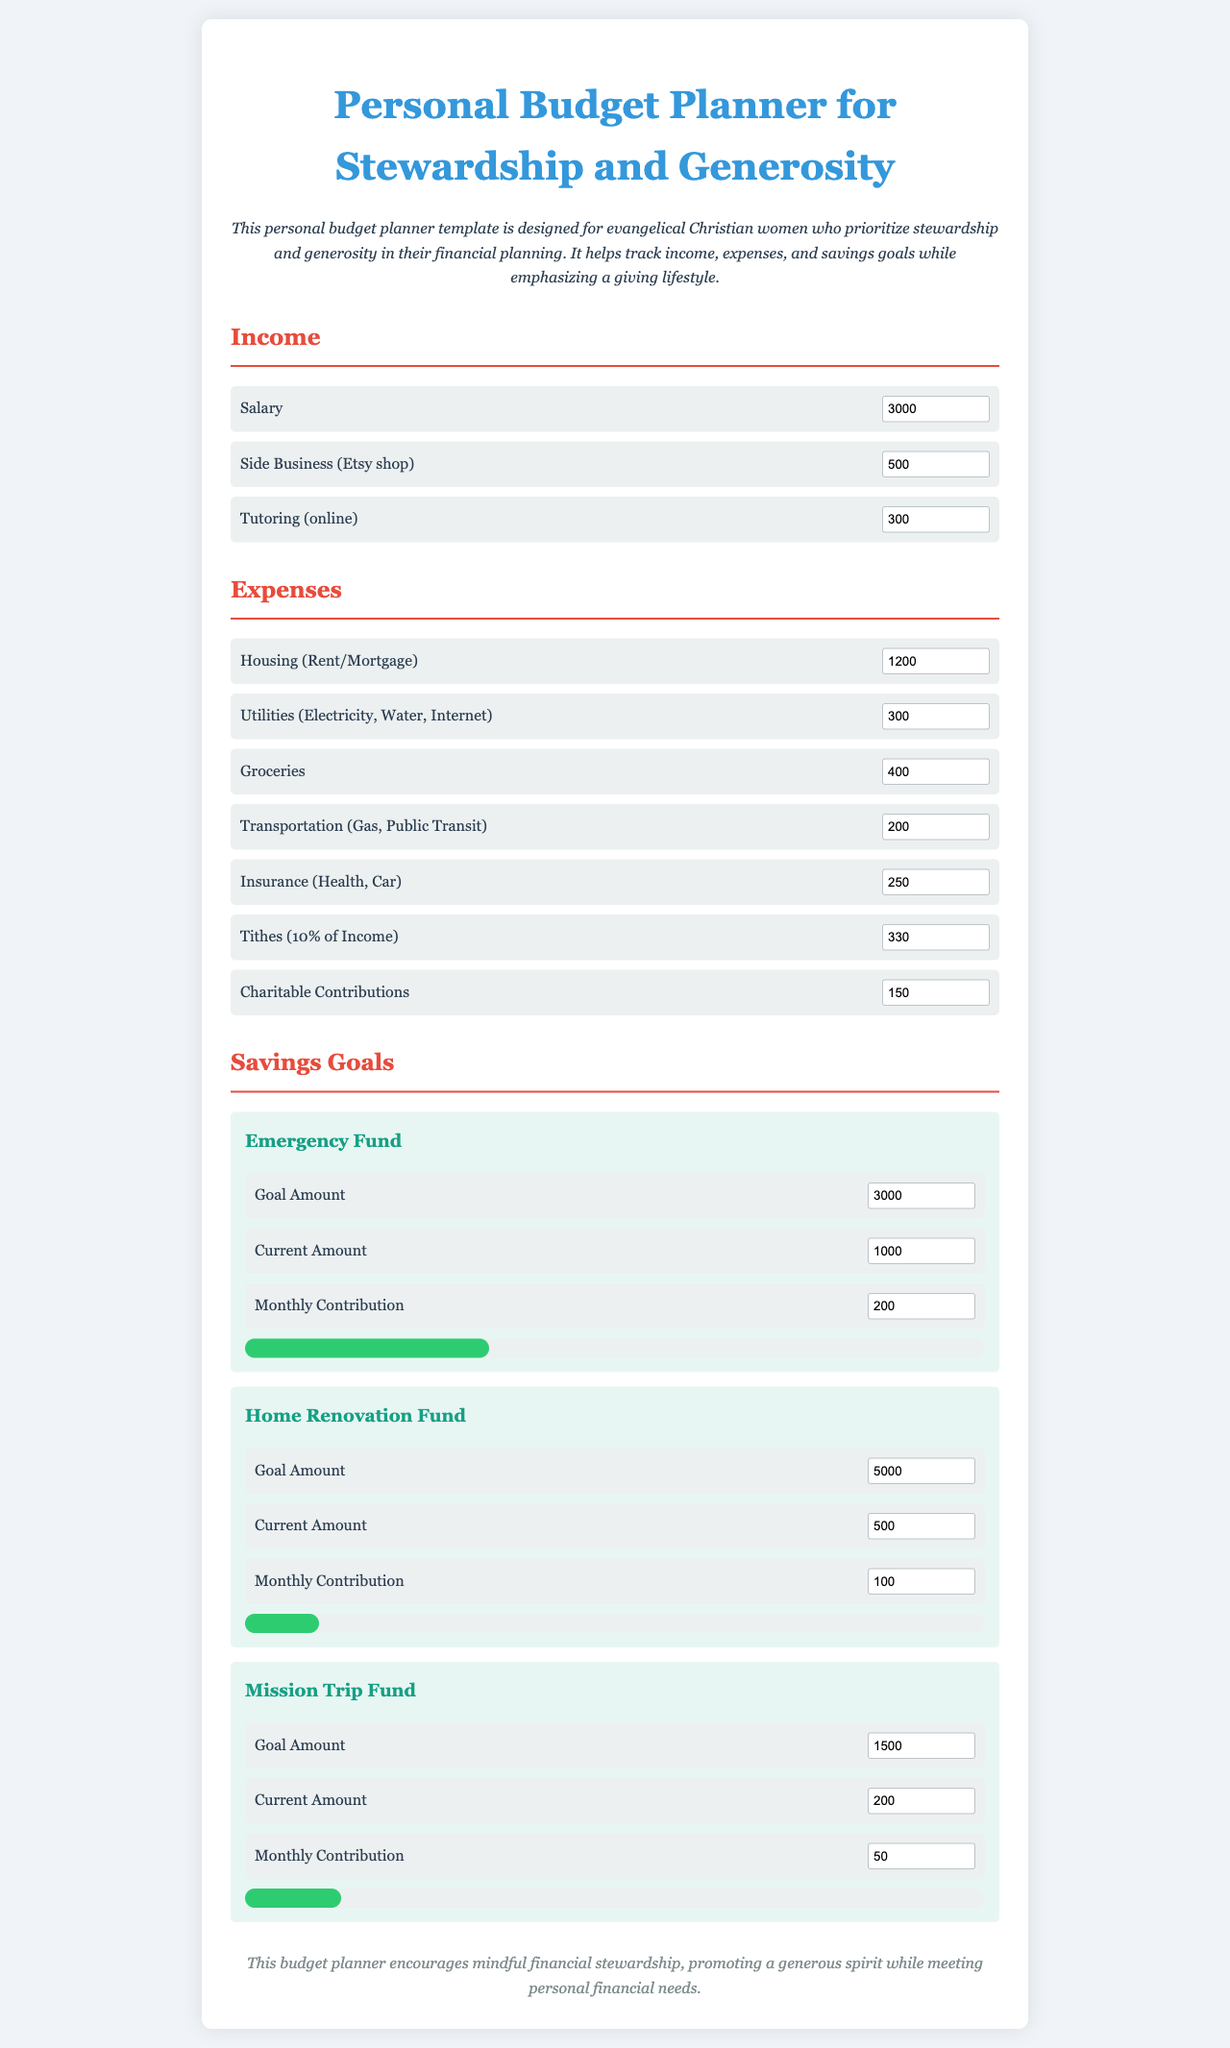What is the total monthly income? The total monthly income is calculated by adding the salary, side business, and tutoring incomes together, which is $3000 + $500 + $300 = $3800.
Answer: $3800 What is the amount allocated for utilities? The utilities expense is specified in the document as $300.
Answer: $300 How much is the savings goal for the Emergency Fund? The goal amount for the Emergency Fund is stated as $3000.
Answer: $3000 What percentage of the Emergency Fund goal is currently saved? The current amount of $1000 out of a goal of $3000 means 33% of the goal is saved.
Answer: 33% What is the total amount budgeted for charitable contributions? The budget for charitable contributions is indicated as $150.
Answer: $150 What is the monthly contribution for the Mission Trip Fund? The monthly contribution dedicated to the Mission Trip Fund is $50.
Answer: $50 How much is the current amount saved for the Home Renovation Fund? The current amount saved for the Home Renovation Fund is noted as $500.
Answer: $500 What type of financial planning does this budget planner focus on? The budget planner focuses on stewardship and generosity in financial planning.
Answer: stewardship and generosity What is the expense category that includes Tithes? The expense category that includes Tithes is categorized under donations and is calculated as 10% of income.
Answer: Tithes 